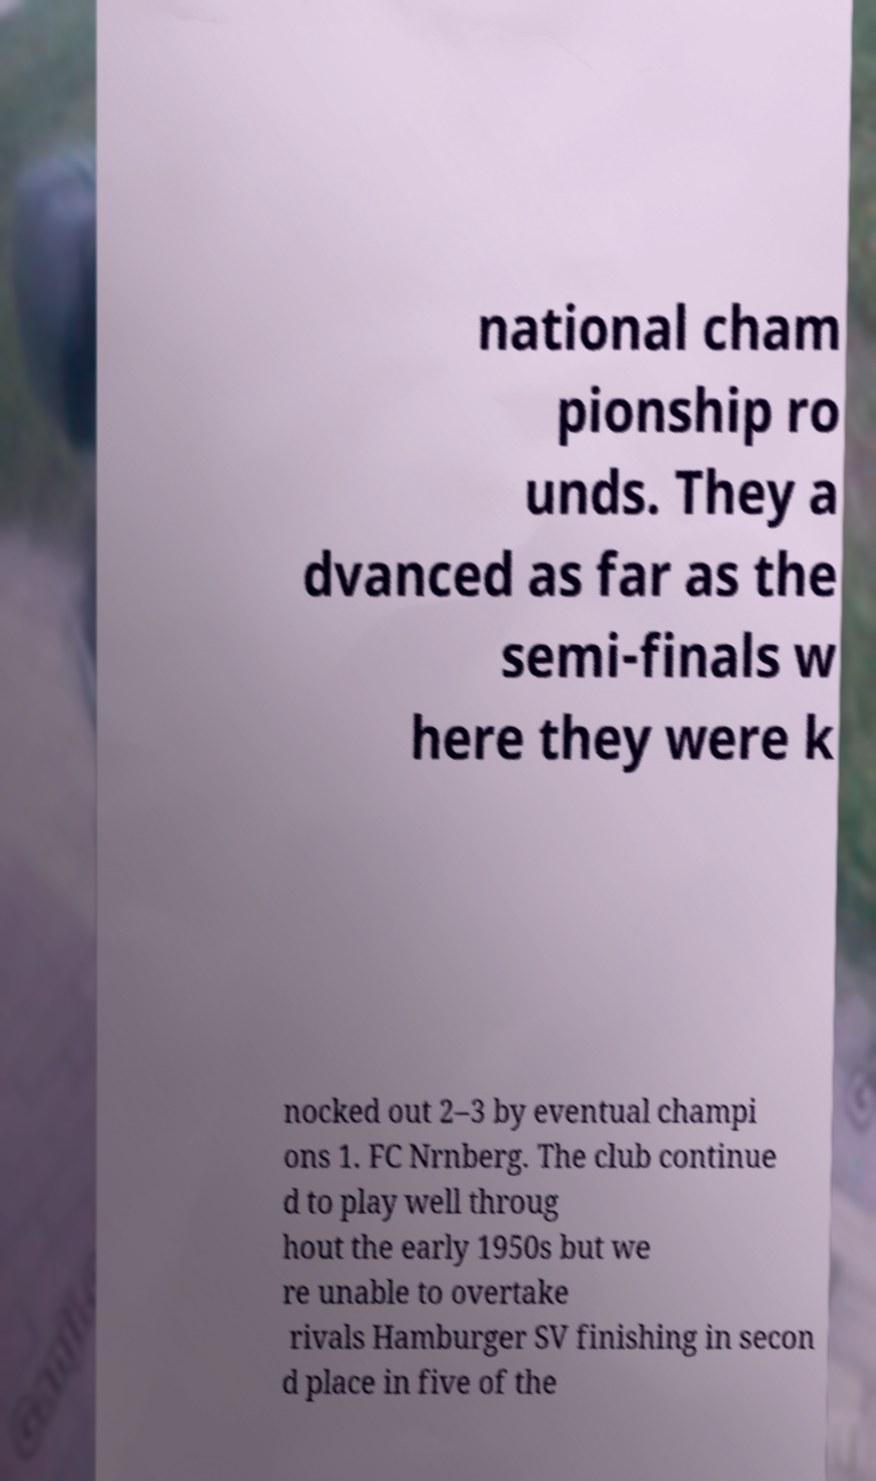For documentation purposes, I need the text within this image transcribed. Could you provide that? national cham pionship ro unds. They a dvanced as far as the semi-finals w here they were k nocked out 2–3 by eventual champi ons 1. FC Nrnberg. The club continue d to play well throug hout the early 1950s but we re unable to overtake rivals Hamburger SV finishing in secon d place in five of the 